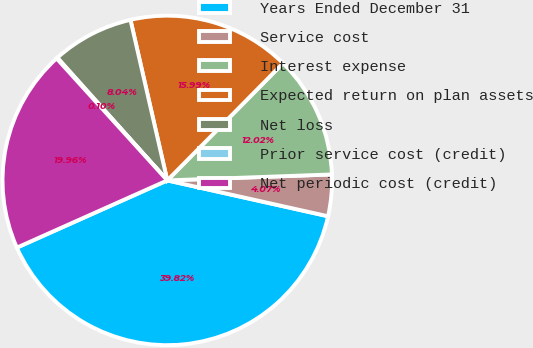Convert chart. <chart><loc_0><loc_0><loc_500><loc_500><pie_chart><fcel>Years Ended December 31<fcel>Service cost<fcel>Interest expense<fcel>Expected return on plan assets<fcel>Net loss<fcel>Prior service cost (credit)<fcel>Net periodic cost (credit)<nl><fcel>39.82%<fcel>4.07%<fcel>12.02%<fcel>15.99%<fcel>8.04%<fcel>0.1%<fcel>19.96%<nl></chart> 